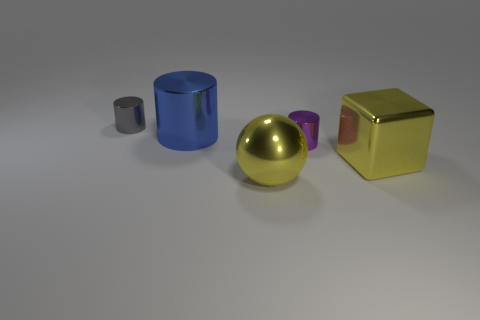The yellow ball that is made of the same material as the gray cylinder is what size?
Your response must be concise. Large. There is a large thing that is both left of the yellow cube and in front of the large blue object; what is its shape?
Provide a short and direct response. Sphere. There is a tiny shiny object that is on the left side of the yellow metallic sphere; is it the same color as the big cylinder?
Keep it short and to the point. No. Does the small shiny object that is in front of the tiny gray metallic thing have the same shape as the small shiny thing that is behind the big blue thing?
Give a very brief answer. Yes. What is the size of the metallic sphere in front of the gray cylinder?
Offer a terse response. Large. How big is the yellow metallic thing that is behind the large yellow metal object left of the purple shiny thing?
Keep it short and to the point. Large. Is the number of gray metal balls greater than the number of tiny gray cylinders?
Your answer should be very brief. No. Are there more big things to the right of the yellow metallic ball than purple metal objects behind the large block?
Offer a very short reply. No. There is a thing that is behind the big yellow cube and in front of the large blue thing; what is its size?
Ensure brevity in your answer.  Small. How many metallic things have the same size as the blue metallic cylinder?
Offer a very short reply. 2. 